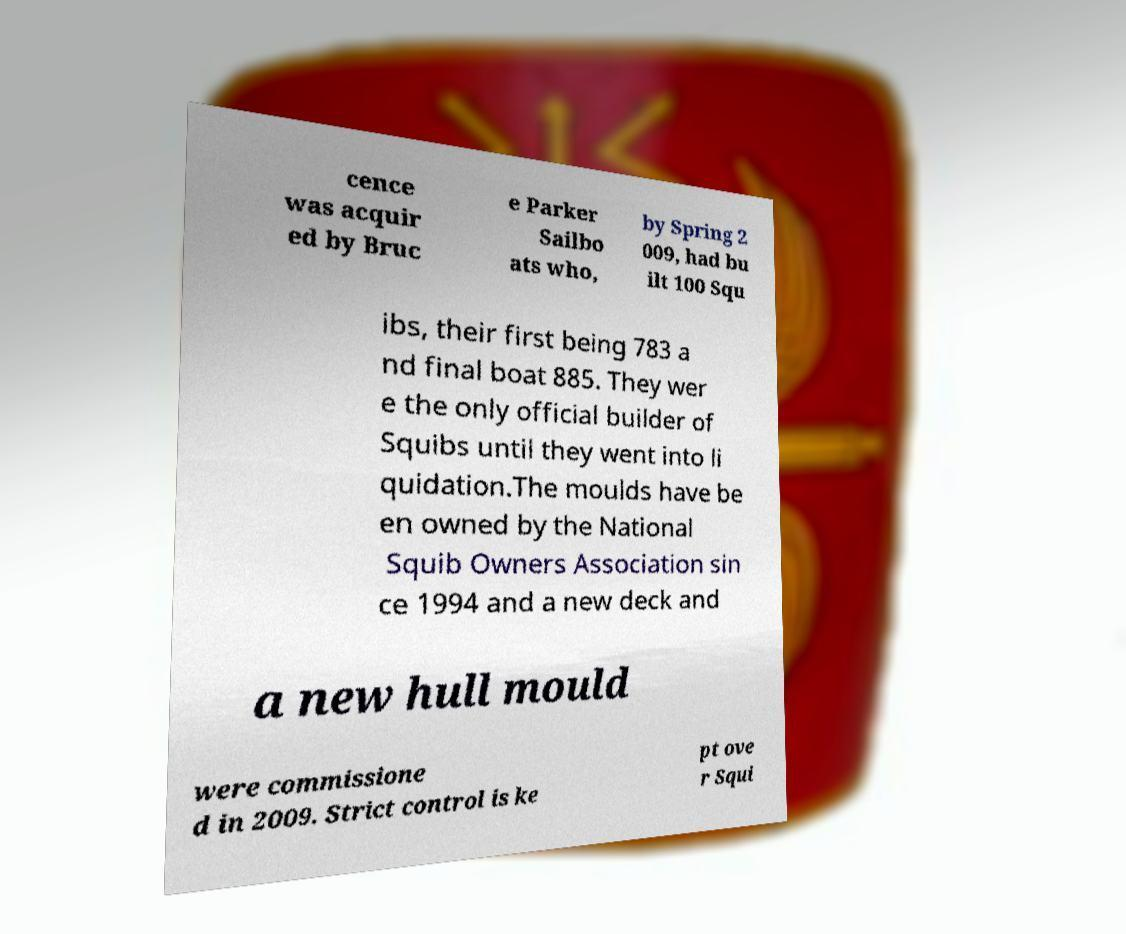Could you extract and type out the text from this image? cence was acquir ed by Bruc e Parker Sailbo ats who, by Spring 2 009, had bu ilt 100 Squ ibs, their first being 783 a nd final boat 885. They wer e the only official builder of Squibs until they went into li quidation.The moulds have be en owned by the National Squib Owners Association sin ce 1994 and a new deck and a new hull mould were commissione d in 2009. Strict control is ke pt ove r Squi 